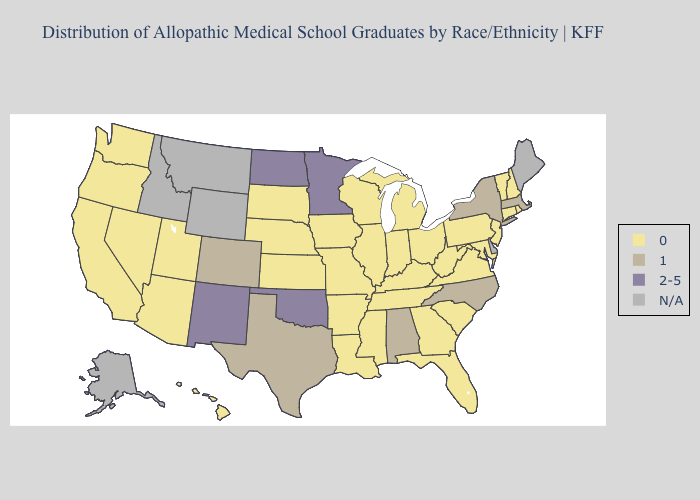What is the value of California?
Short answer required. 0. What is the lowest value in states that border Indiana?
Write a very short answer. 0. Among the states that border Georgia , which have the lowest value?
Write a very short answer. Florida, South Carolina, Tennessee. What is the lowest value in the Northeast?
Write a very short answer. 0. Does Colorado have the lowest value in the USA?
Keep it brief. No. What is the value of Mississippi?
Concise answer only. 0. Name the states that have a value in the range N/A?
Keep it brief. Alaska, Delaware, Idaho, Maine, Montana, Wyoming. Does Pennsylvania have the highest value in the Northeast?
Give a very brief answer. No. Is the legend a continuous bar?
Keep it brief. No. Which states have the lowest value in the Northeast?
Write a very short answer. Connecticut, New Hampshire, New Jersey, Pennsylvania, Rhode Island, Vermont. Name the states that have a value in the range 1?
Give a very brief answer. Alabama, Colorado, Massachusetts, New York, North Carolina, Texas. What is the lowest value in the South?
Keep it brief. 0. Name the states that have a value in the range 2-5?
Keep it brief. Minnesota, New Mexico, North Dakota, Oklahoma. What is the highest value in the Northeast ?
Concise answer only. 1. 